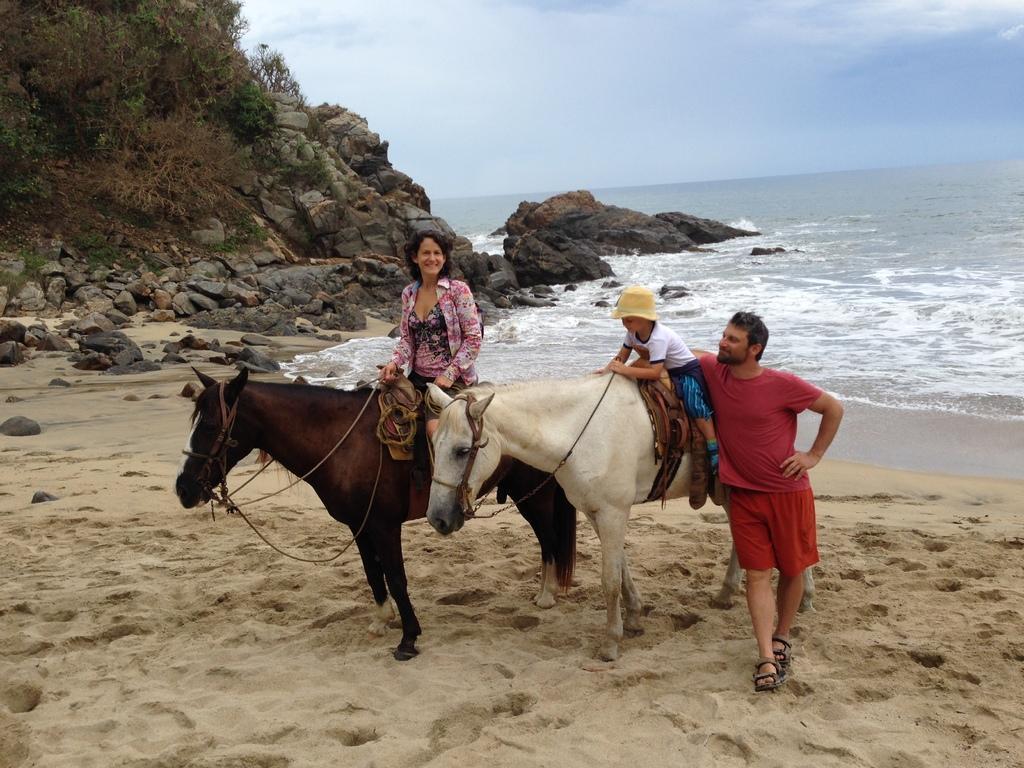Can you describe this image briefly? Completely an outdoor picture. These are stones. This is a freshwater river. This woman is sitting on a brown horse. This kid is sitting on a white horse. This man is standing beside his horse. This is sand. 